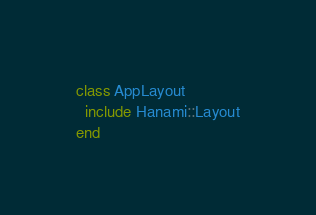Convert code to text. <code><loc_0><loc_0><loc_500><loc_500><_Ruby_>class AppLayout
  include Hanami::Layout
end
</code> 